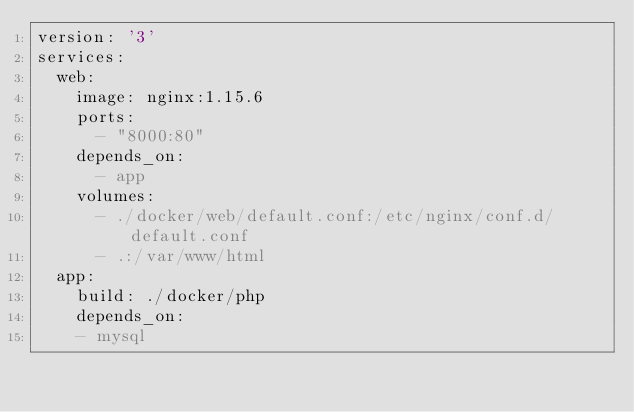Convert code to text. <code><loc_0><loc_0><loc_500><loc_500><_YAML_>version: '3'
services:
  web:
    image: nginx:1.15.6
    ports:
      - "8000:80"
    depends_on:
      - app
    volumes:
      - ./docker/web/default.conf:/etc/nginx/conf.d/default.conf
      - .:/var/www/html
  app:
    build: ./docker/php
    depends_on:
    - mysql</code> 